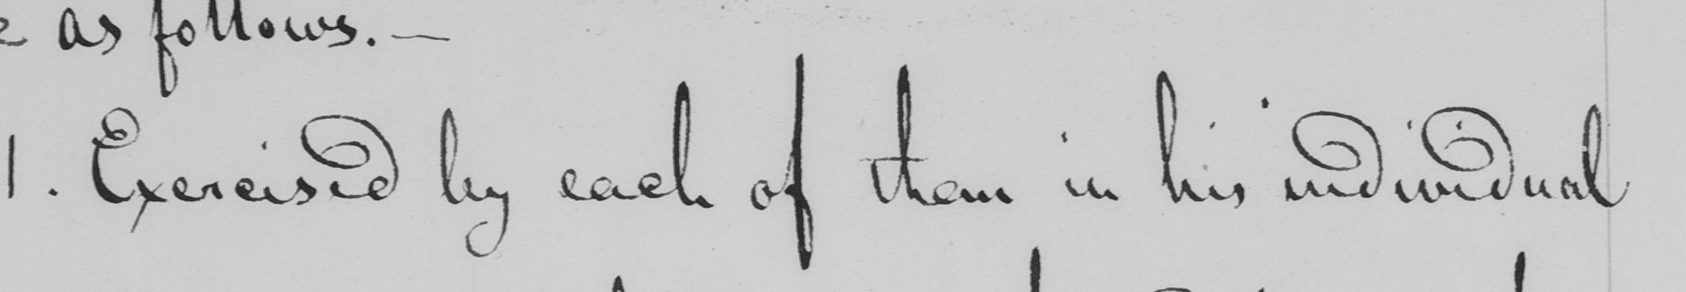Please transcribe the handwritten text in this image. 1 . Exercised by each of them in his individual 